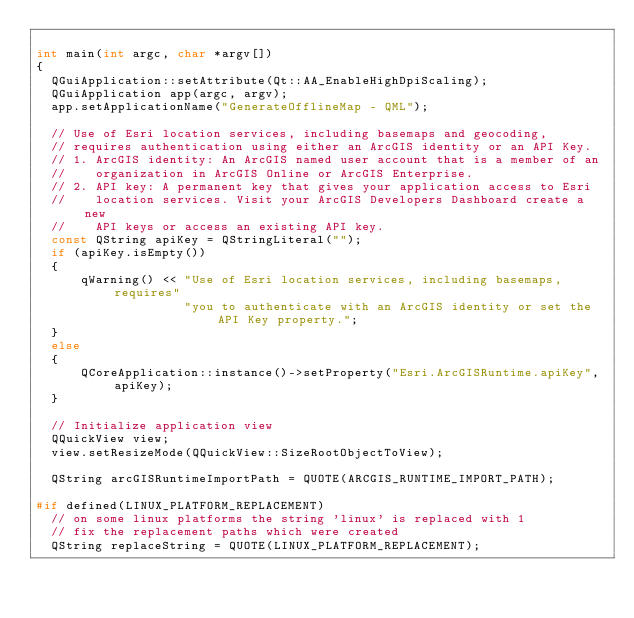<code> <loc_0><loc_0><loc_500><loc_500><_C++_>
int main(int argc, char *argv[])
{
  QGuiApplication::setAttribute(Qt::AA_EnableHighDpiScaling);
  QGuiApplication app(argc, argv);
  app.setApplicationName("GenerateOfflineMap - QML");

  // Use of Esri location services, including basemaps and geocoding,
  // requires authentication using either an ArcGIS identity or an API Key.
  // 1. ArcGIS identity: An ArcGIS named user account that is a member of an
  //    organization in ArcGIS Online or ArcGIS Enterprise.
  // 2. API key: A permanent key that gives your application access to Esri
  //    location services. Visit your ArcGIS Developers Dashboard create a new
  //    API keys or access an existing API key.
  const QString apiKey = QStringLiteral("");
  if (apiKey.isEmpty())
  {
      qWarning() << "Use of Esri location services, including basemaps, requires"
                    "you to authenticate with an ArcGIS identity or set the API Key property.";
  }
  else
  {
      QCoreApplication::instance()->setProperty("Esri.ArcGISRuntime.apiKey", apiKey);
  }

  // Initialize application view
  QQuickView view;
  view.setResizeMode(QQuickView::SizeRootObjectToView);

  QString arcGISRuntimeImportPath = QUOTE(ARCGIS_RUNTIME_IMPORT_PATH);

#if defined(LINUX_PLATFORM_REPLACEMENT)
  // on some linux platforms the string 'linux' is replaced with 1
  // fix the replacement paths which were created
  QString replaceString = QUOTE(LINUX_PLATFORM_REPLACEMENT);</code> 